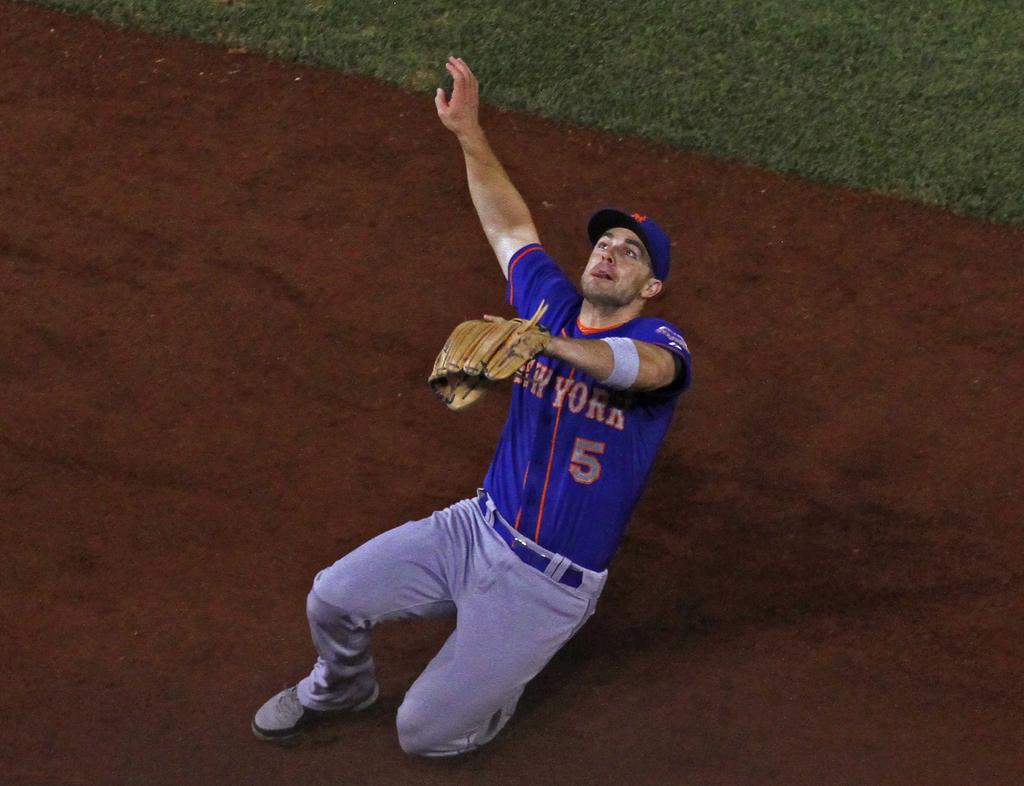<image>
Summarize the visual content of the image. The New York Baseball player was actively participating in the sport. 